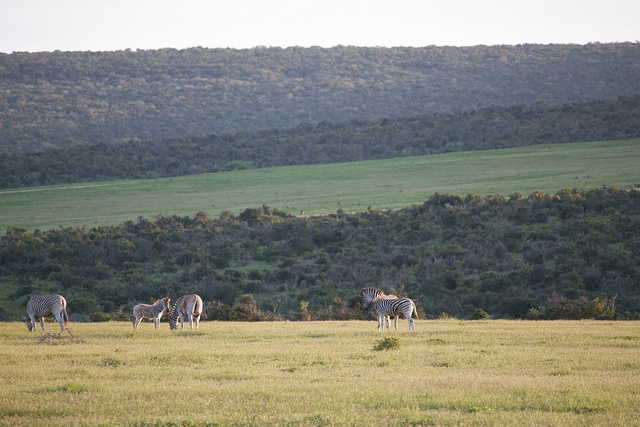Describe the objects in this image and their specific colors. I can see zebra in white, gray, and black tones, zebra in white, gray, black, and tan tones, zebra in white, gray, darkgray, and black tones, zebra in white, gray, darkgray, and tan tones, and zebra in white, gray, and tan tones in this image. 